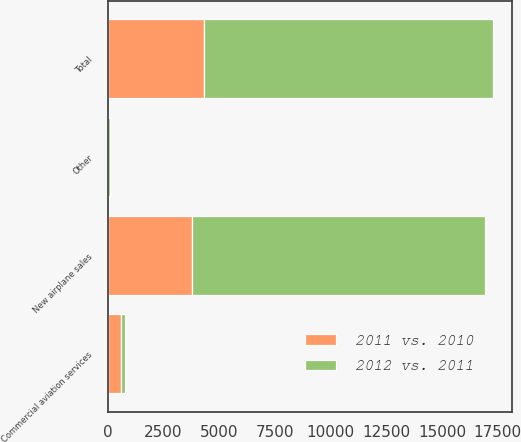Convert chart. <chart><loc_0><loc_0><loc_500><loc_500><stacked_bar_chart><ecel><fcel>New airplane sales<fcel>Commercial aviation services<fcel>Other<fcel>Total<nl><fcel>2012 vs. 2011<fcel>13185<fcel>161<fcel>68<fcel>12956<nl><fcel>2011 vs. 2010<fcel>3766<fcel>594<fcel>23<fcel>4337<nl></chart> 